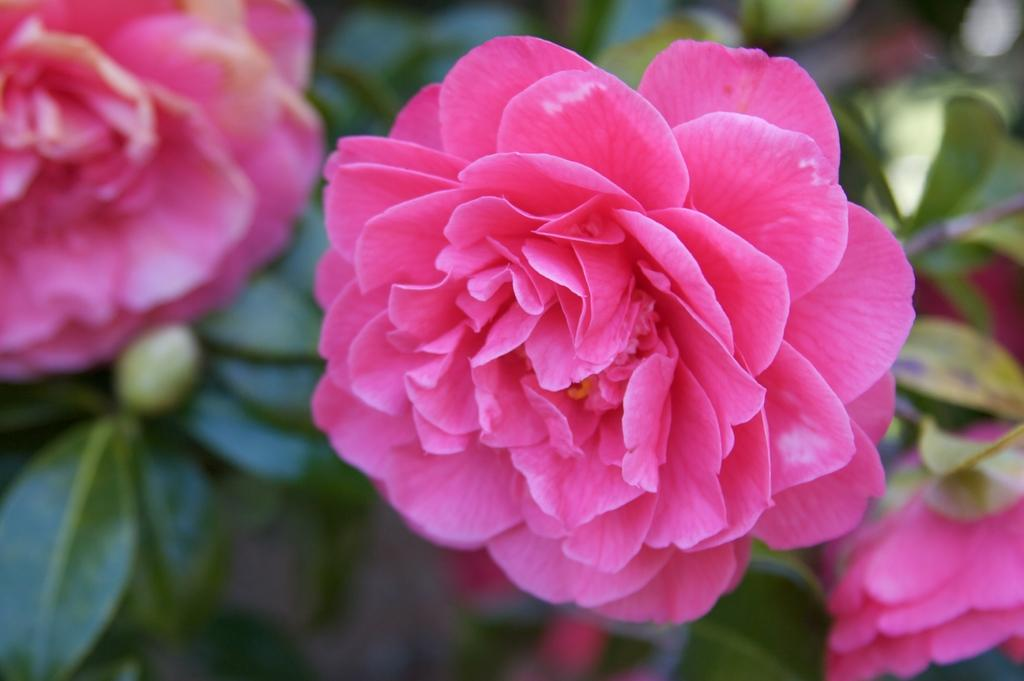What type of flower is in the foreground of the image? There is a pink rose flower in the foreground of the image. Where can more rose flowers be found in the image? Rose flowers can be found on the bottom right corner and the top left corner of the image. What is the sound of the thunder like in the image? There is no mention of thunder in the image, as it is focused on rose flowers. 